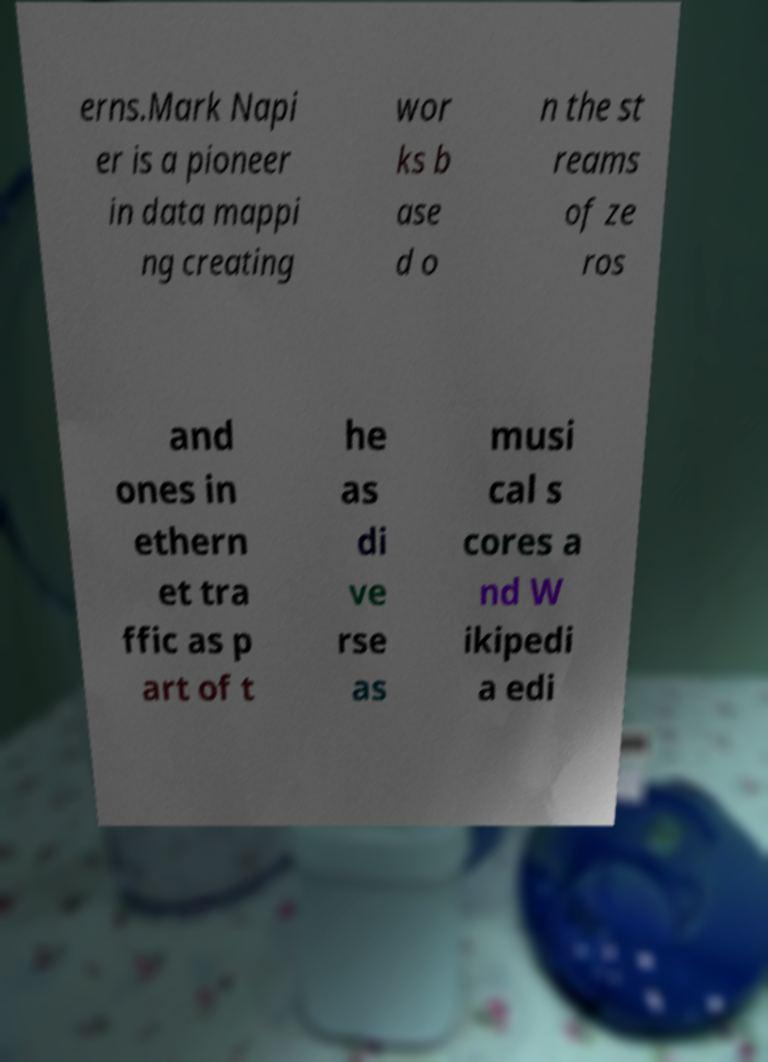Please read and relay the text visible in this image. What does it say? erns.Mark Napi er is a pioneer in data mappi ng creating wor ks b ase d o n the st reams of ze ros and ones in ethern et tra ffic as p art of t he as di ve rse as musi cal s cores a nd W ikipedi a edi 